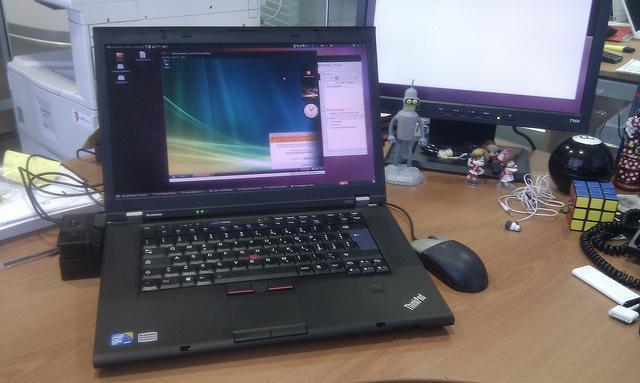How many keyboards do you see?
Give a very brief answer. 1. How many remotes are on the table?
Give a very brief answer. 0. How many keyboards are visible?
Give a very brief answer. 1. 